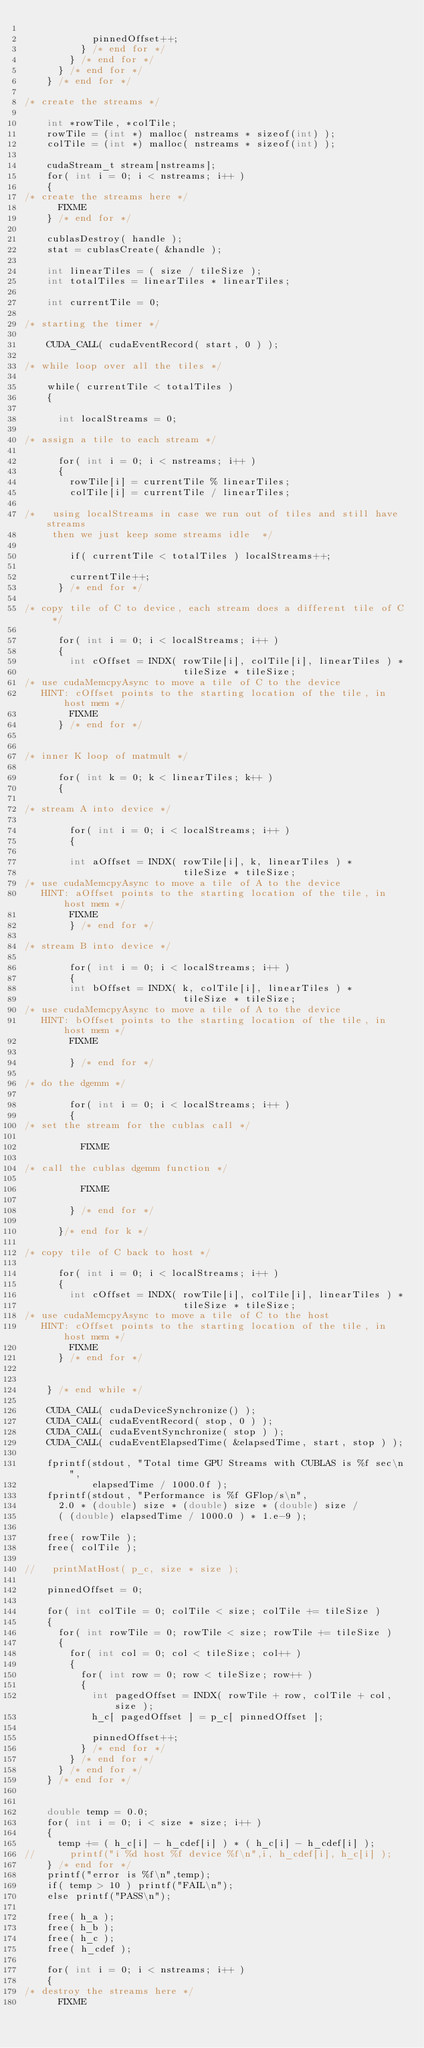Convert code to text. <code><loc_0><loc_0><loc_500><loc_500><_Cuda_>
            pinnedOffset++;
          } /* end for */
        } /* end for */
      } /* end for */
    } /* end for */

/* create the streams */

    int *rowTile, *colTile;
    rowTile = (int *) malloc( nstreams * sizeof(int) );
    colTile = (int *) malloc( nstreams * sizeof(int) );

    cudaStream_t stream[nstreams];
    for( int i = 0; i < nstreams; i++ )
    {
/* create the streams here */
      FIXME
    } /* end for */

    cublasDestroy( handle );
    stat = cublasCreate( &handle );

    int linearTiles = ( size / tileSize );
    int totalTiles = linearTiles * linearTiles;

    int currentTile = 0;

/* starting the timer */

    CUDA_CALL( cudaEventRecord( start, 0 ) );

/* while loop over all the tiles */

    while( currentTile < totalTiles )
    {

      int localStreams = 0;

/* assign a tile to each stream */

      for( int i = 0; i < nstreams; i++ )
      {
        rowTile[i] = currentTile % linearTiles;
        colTile[i] = currentTile / linearTiles;

/*   using localStreams in case we run out of tiles and still have streams
     then we just keep some streams idle  */

        if( currentTile < totalTiles ) localStreams++;

        currentTile++;
      } /* end for */

/* copy tile of C to device, each stream does a different tile of C */

      for( int i = 0; i < localStreams; i++ )
      {
        int cOffset = INDX( rowTile[i], colTile[i], linearTiles ) *
                            tileSize * tileSize;
/* use cudaMemcpyAsync to move a tile of C to the device
   HINT: cOffset points to the starting location of the tile, in host mem */
        FIXME
      } /* end for */


/* inner K loop of matmult */

      for( int k = 0; k < linearTiles; k++ )
      {

/* stream A into device */

        for( int i = 0; i < localStreams; i++ )
        {

        int aOffset = INDX( rowTile[i], k, linearTiles ) *
                            tileSize * tileSize;
/* use cudaMemcpyAsync to move a tile of A to the device
   HINT: aOffset points to the starting location of the tile, in host mem */
        FIXME
        } /* end for */

/* stream B into device */

        for( int i = 0; i < localStreams; i++ )
        {
        int bOffset = INDX( k, colTile[i], linearTiles ) *
                            tileSize * tileSize;
/* use cudaMemcpyAsync to move a tile of A to the device
   HINT: bOffset points to the starting location of the tile, in host mem */
        FIXME

        } /* end for */

/* do the dgemm */

        for( int i = 0; i < localStreams; i++ )
        {
/* set the stream for the cublas call */

          FIXME

/* call the cublas dgemm function */

          FIXME

        } /* end for */

      }/* end for k */

/* copy tile of C back to host */

      for( int i = 0; i < localStreams; i++ )
      {
        int cOffset = INDX( rowTile[i], colTile[i], linearTiles ) *
                            tileSize * tileSize;
/* use cudaMemcpyAsync to move a tile of C to the host
   HINT: cOffset points to the starting location of the tile, in host mem */
        FIXME
      } /* end for */


    } /* end while */

    CUDA_CALL( cudaDeviceSynchronize() );
    CUDA_CALL( cudaEventRecord( stop, 0 ) );
    CUDA_CALL( cudaEventSynchronize( stop ) );
    CUDA_CALL( cudaEventElapsedTime( &elapsedTime, start, stop ) );

    fprintf(stdout, "Total time GPU Streams with CUBLAS is %f sec\n",
            elapsedTime / 1000.0f );
    fprintf(stdout, "Performance is %f GFlop/s\n",
      2.0 * (double) size * (double) size * (double) size /
      ( (double) elapsedTime / 1000.0 ) * 1.e-9 );

    free( rowTile );
    free( colTile );

//   printMatHost( p_c, size * size );

    pinnedOffset = 0;

    for( int colTile = 0; colTile < size; colTile += tileSize )
    {
      for( int rowTile = 0; rowTile < size; rowTile += tileSize )
      {
        for( int col = 0; col < tileSize; col++ )
        {
          for( int row = 0; row < tileSize; row++ )
          {
            int pagedOffset = INDX( rowTile + row, colTile + col, size );
            h_c[ pagedOffset ] = p_c[ pinnedOffset ];

            pinnedOffset++;
          } /* end for */
        } /* end for */
      } /* end for */
    } /* end for */


    double temp = 0.0;
    for( int i = 0; i < size * size; i++ )
    {
      temp += ( h_c[i] - h_cdef[i] ) * ( h_c[i] - h_cdef[i] );
//      printf("i %d host %f device %f\n",i, h_cdef[i], h_c[i] );
    } /* end for */
    printf("error is %f\n",temp);
    if( temp > 10 ) printf("FAIL\n");
    else printf("PASS\n");

    free( h_a );
    free( h_b );
    free( h_c );
    free( h_cdef );

    for( int i = 0; i < nstreams; i++ )
    {
/* destroy the streams here */
      FIXME</code> 